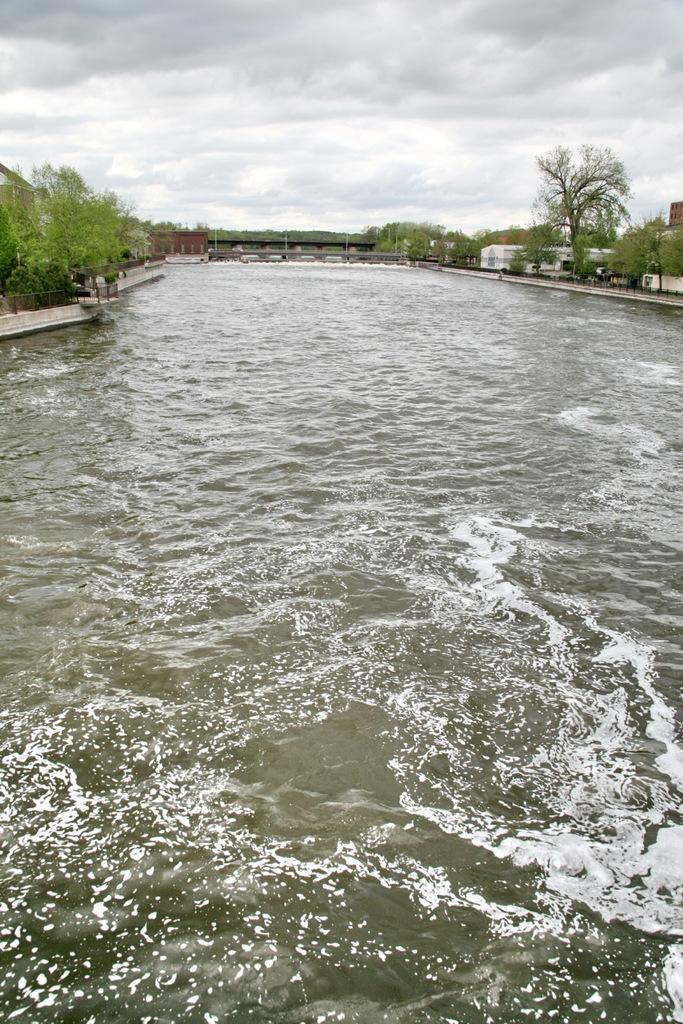In one or two sentences, can you explain what this image depicts? In this image I can see the water. In the background I can see few trees in green color, buildings and the sky is in white color. 